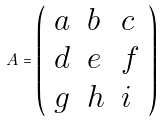Convert formula to latex. <formula><loc_0><loc_0><loc_500><loc_500>A = { \left ( \begin{array} { l l l } { a } & { b } & { c } \\ { d } & { e } & { f } \\ { g } & { h } & { i } \end{array} \right ) }</formula> 